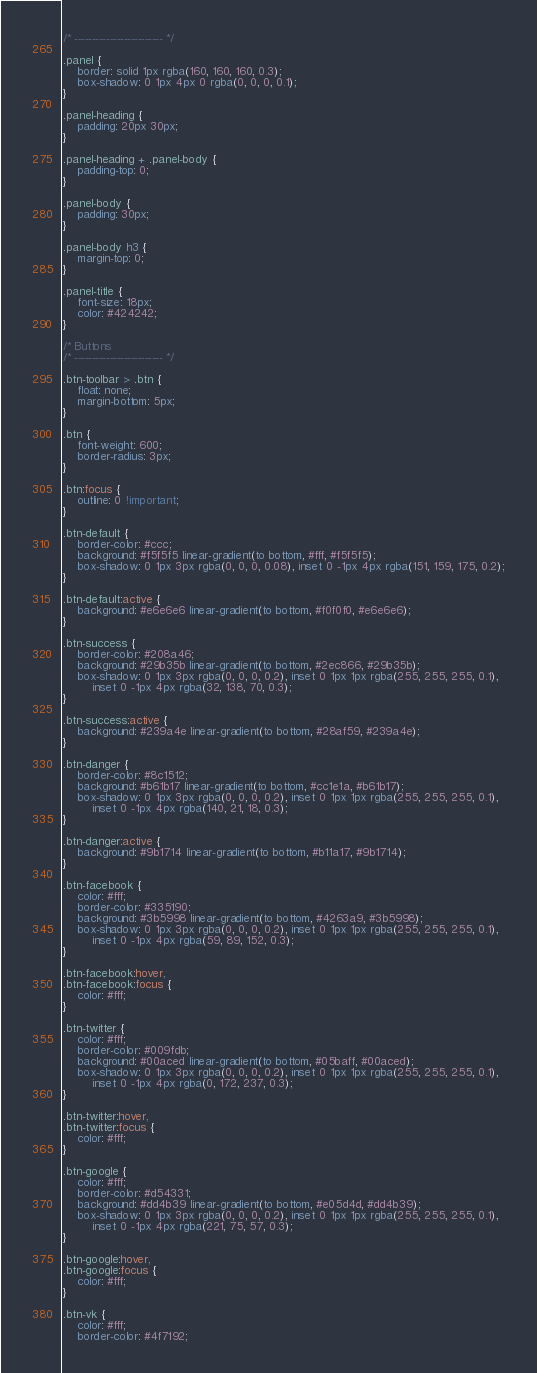Convert code to text. <code><loc_0><loc_0><loc_500><loc_500><_CSS_>/* ------------------------- */

.panel {
	border: solid 1px rgba(160, 160, 160, 0.3);
	box-shadow: 0 1px 4px 0 rgba(0, 0, 0, 0.1);
}

.panel-heading {
	padding: 20px 30px;
}

.panel-heading + .panel-body {
	padding-top: 0;
}

.panel-body {
	padding: 30px;
}

.panel-body h3 {
	margin-top: 0;
}

.panel-title {
	font-size: 18px;
	color: #424242;
}

/* Buttons
/* ------------------------- */

.btn-toolbar > .btn {
	float: none;
	margin-bottom: 5px;
}

.btn {
	font-weight: 600;
	border-radius: 3px;
}

.btn:focus {
	outline: 0 !important;
}

.btn-default {
	border-color: #ccc;
	background: #f5f5f5 linear-gradient(to bottom, #fff, #f5f5f5);
	box-shadow: 0 1px 3px rgba(0, 0, 0, 0.08), inset 0 -1px 4px rgba(151, 159, 175, 0.2);
}

.btn-default:active {
	background: #e6e6e6 linear-gradient(to bottom, #f0f0f0, #e6e6e6);
}

.btn-success {
	border-color: #208a46;
	background: #29b35b linear-gradient(to bottom, #2ec866, #29b35b);
	box-shadow: 0 1px 3px rgba(0, 0, 0, 0.2), inset 0 1px 1px rgba(255, 255, 255, 0.1),
		inset 0 -1px 4px rgba(32, 138, 70, 0.3);
}

.btn-success:active {
	background: #239a4e linear-gradient(to bottom, #28af59, #239a4e);
}

.btn-danger {
	border-color: #8c1512;
	background: #b61b17 linear-gradient(to bottom, #cc1e1a, #b61b17);
	box-shadow: 0 1px 3px rgba(0, 0, 0, 0.2), inset 0 1px 1px rgba(255, 255, 255, 0.1),
		inset 0 -1px 4px rgba(140, 21, 18, 0.3);
}

.btn-danger:active {
	background: #9b1714 linear-gradient(to bottom, #b11a17, #9b1714);
}

.btn-facebook {
	color: #fff;
	border-color: #335190;
	background: #3b5998 linear-gradient(to bottom, #4263a9, #3b5998);
	box-shadow: 0 1px 3px rgba(0, 0, 0, 0.2), inset 0 1px 1px rgba(255, 255, 255, 0.1),
		inset 0 -1px 4px rgba(59, 89, 152, 0.3);
}

.btn-facebook:hover,
.btn-facebook:focus {
	color: #fff;
}

.btn-twitter {
	color: #fff;
	border-color: #009fdb;
	background: #00aced linear-gradient(to bottom, #05baff, #00aced);
	box-shadow: 0 1px 3px rgba(0, 0, 0, 0.2), inset 0 1px 1px rgba(255, 255, 255, 0.1),
		inset 0 -1px 4px rgba(0, 172, 237, 0.3);
}

.btn-twitter:hover,
.btn-twitter:focus {
	color: #fff;
}

.btn-google {
	color: #fff;
	border-color: #d54331;
	background: #dd4b39 linear-gradient(to bottom, #e05d4d, #dd4b39);
	box-shadow: 0 1px 3px rgba(0, 0, 0, 0.2), inset 0 1px 1px rgba(255, 255, 255, 0.1),
		inset 0 -1px 4px rgba(221, 75, 57, 0.3);
}

.btn-google:hover,
.btn-google:focus {
	color: #fff;
}

.btn-vk {
	color: #fff;
	border-color: #4f7192;</code> 